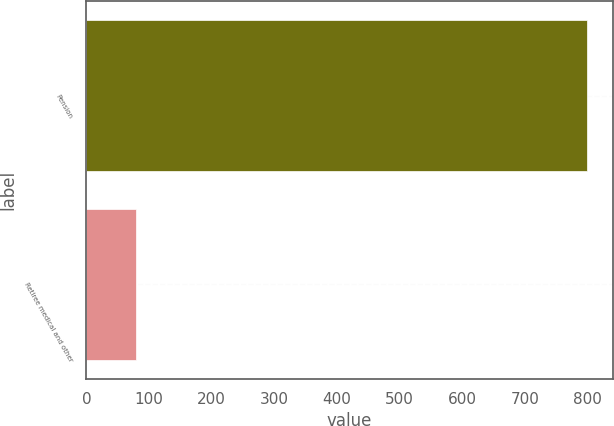Convert chart to OTSL. <chart><loc_0><loc_0><loc_500><loc_500><bar_chart><fcel>Pension<fcel>Retiree medical and other<nl><fcel>800<fcel>79<nl></chart> 